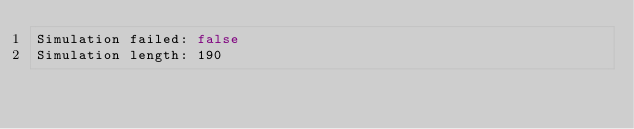<code> <loc_0><loc_0><loc_500><loc_500><_YAML_>Simulation failed: false
Simulation length: 190
</code> 